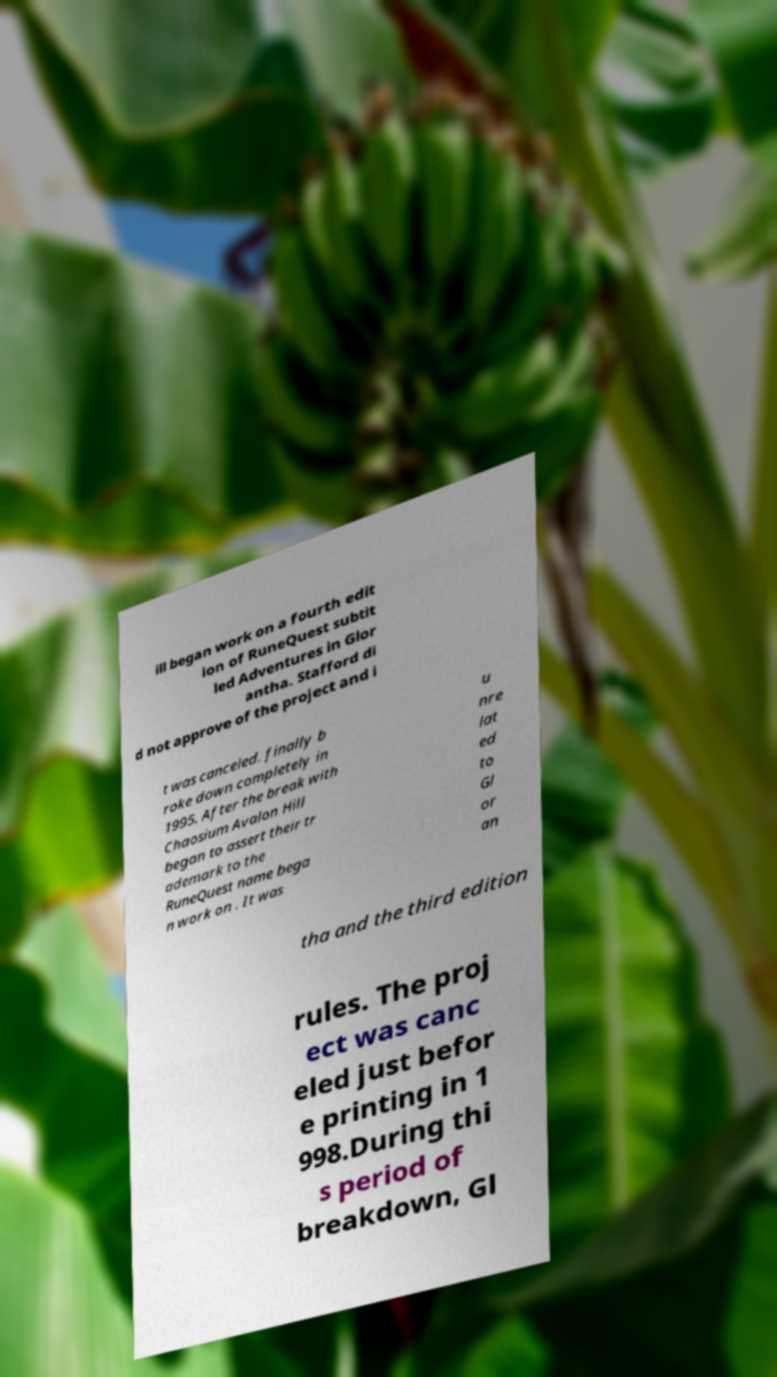Please read and relay the text visible in this image. What does it say? ill began work on a fourth edit ion of RuneQuest subtit led Adventures in Glor antha. Stafford di d not approve of the project and i t was canceled. finally b roke down completely in 1995. After the break with Chaosium Avalon Hill began to assert their tr ademark to the RuneQuest name bega n work on . It was u nre lat ed to Gl or an tha and the third edition rules. The proj ect was canc eled just befor e printing in 1 998.During thi s period of breakdown, Gl 